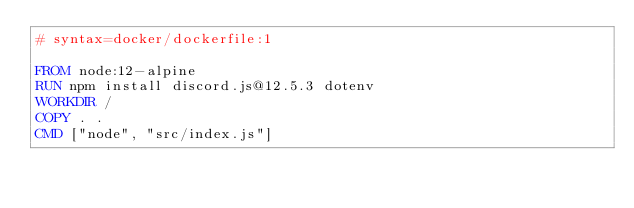Convert code to text. <code><loc_0><loc_0><loc_500><loc_500><_Dockerfile_># syntax=docker/dockerfile:1

FROM node:12-alpine
RUN npm install discord.js@12.5.3 dotenv
WORKDIR /
COPY . .
CMD ["node", "src/index.js"]
</code> 